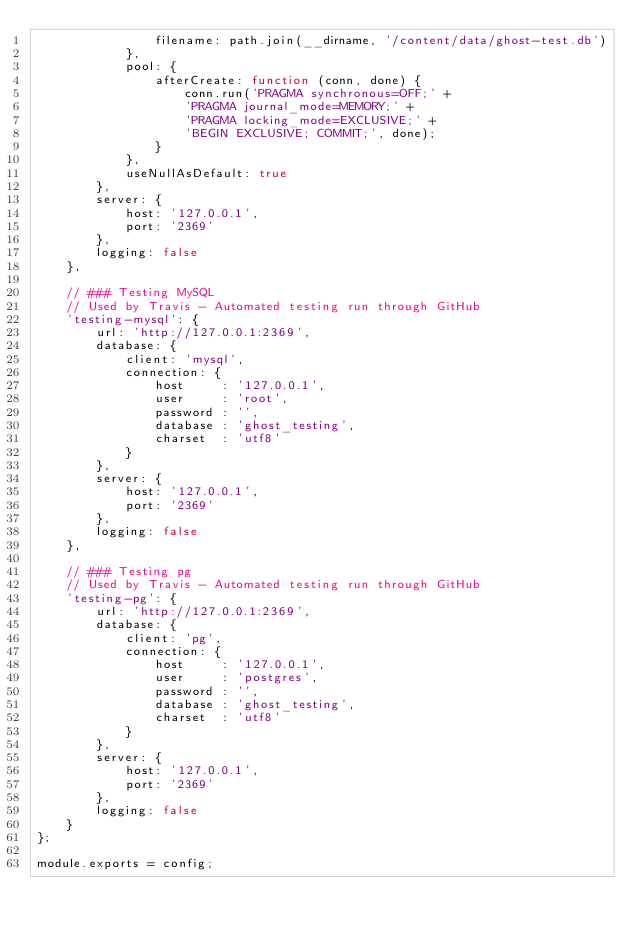<code> <loc_0><loc_0><loc_500><loc_500><_JavaScript_>                filename: path.join(__dirname, '/content/data/ghost-test.db')
            },
            pool: {
                afterCreate: function (conn, done) {
                    conn.run('PRAGMA synchronous=OFF;' +
                    'PRAGMA journal_mode=MEMORY;' +
                    'PRAGMA locking_mode=EXCLUSIVE;' +
                    'BEGIN EXCLUSIVE; COMMIT;', done);
                }
            },
            useNullAsDefault: true
        },
        server: {
            host: '127.0.0.1',
            port: '2369'
        },
        logging: false
    },

    // ### Testing MySQL
    // Used by Travis - Automated testing run through GitHub
    'testing-mysql': {
        url: 'http://127.0.0.1:2369',
        database: {
            client: 'mysql',
            connection: {
                host     : '127.0.0.1',
                user     : 'root',
                password : '',
                database : 'ghost_testing',
                charset  : 'utf8'
            }
        },
        server: {
            host: '127.0.0.1',
            port: '2369'
        },
        logging: false
    },

    // ### Testing pg
    // Used by Travis - Automated testing run through GitHub
    'testing-pg': {
        url: 'http://127.0.0.1:2369',
        database: {
            client: 'pg',
            connection: {
                host     : '127.0.0.1',
                user     : 'postgres',
                password : '',
                database : 'ghost_testing',
                charset  : 'utf8'
            }
        },
        server: {
            host: '127.0.0.1',
            port: '2369'
        },
        logging: false
    }
};

module.exports = config;
</code> 